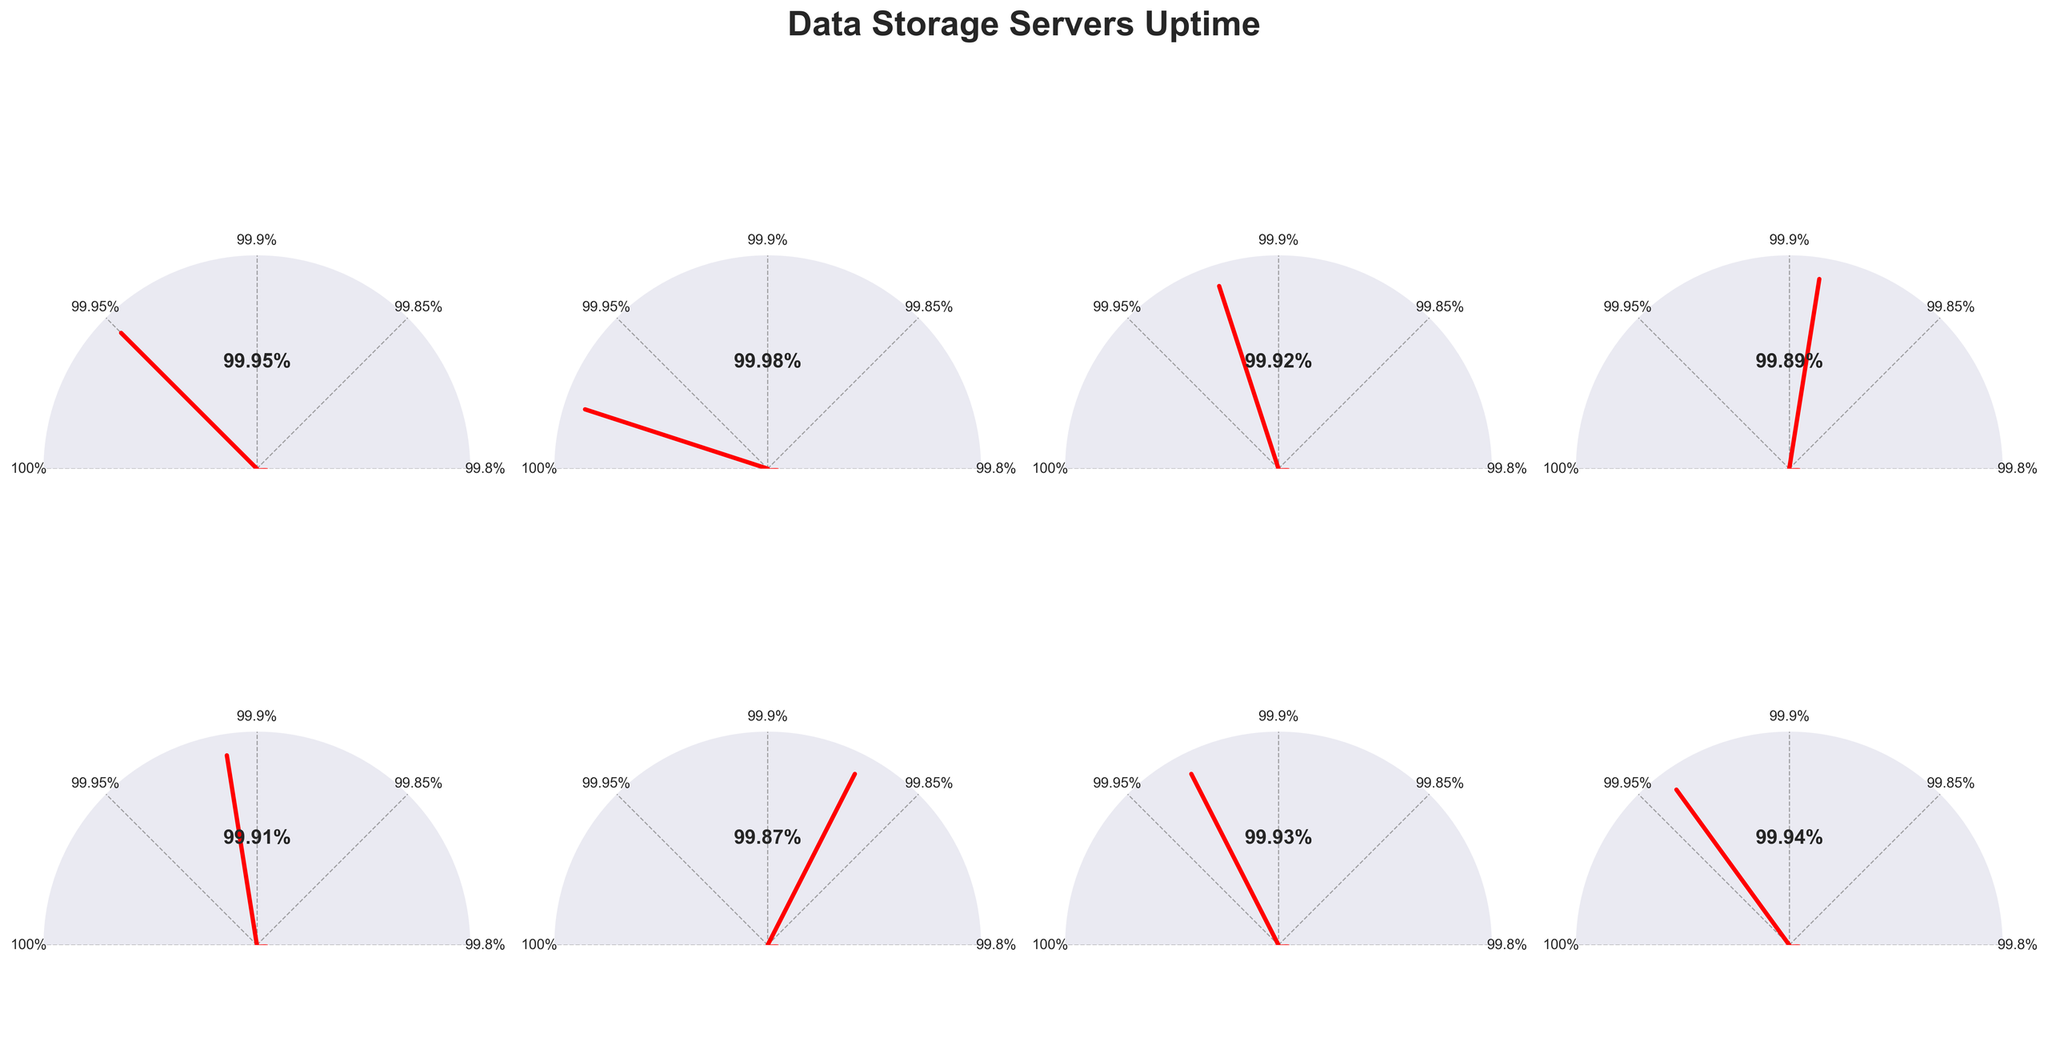What is the title of the figure? The title of the figure is displayed at the top of the plot in a large, bold font. It is "Data Storage Servers Uptime."
Answer: Data Storage Servers Uptime Which server has the highest uptime percentage? To determine the highest uptime percentage, we need to compare the percentage values for all servers. Google's uptime percentage of 99.98% is the highest among all.
Answer: Google Cloud Storage How many data storage servers are represented in the figure? Counting the number of gauges, each representing a different server, shows that there are 8 data storage servers in total.
Answer: 8 Which server shows below 99.9% uptime? To find servers with uptime below 99.9%, we look at the gauges and see: IBM Cloud Storage, Oracle Cloud Storage, Dropbox Business.
Answer: Three servers (IBM Cloud Storage, Oracle Cloud Storage, Dropbox Business) Which server has the lowest uptime percentage? By comparing all the uptime percentages, the lowest value is 99.87% for Dropbox Business.
Answer: Dropbox Business What is the average uptime percentage across all servers? To find the average, add all percentages: (99.95 + 99.98 + 99.92 + 99.89 + 99.91 + 99.87 + 99.93 + 99.94) = 799.39%, then divide by the number of servers (8), resulting in 99.92375%.
Answer: 99.92375% Is the uptime percentage for Amazon S3 closer to 100% or 99.8%? Amazon S3 has an uptime of 99.95%, which is closer to 100% than 99.8%.
Answer: 100% What does the needle position represent in each gauge chart? Needle position in each gauge chart represents the uptime percentage for the corresponding server, with the angle determined by the uptime value between 99.8% and 100%.
Answer: Uptime percentage Which server has an uptime percentage closest to 99.9%? Comparing all uptime values, Oracle Cloud Storage's uptime (99.91%) is the closest to 99.9%.
Answer: Oracle Cloud Storage Are there any servers with exactly the same uptime percentage? Comparing all uptime percentages, no two servers have the exact same uptime value; each one is unique.
Answer: No 